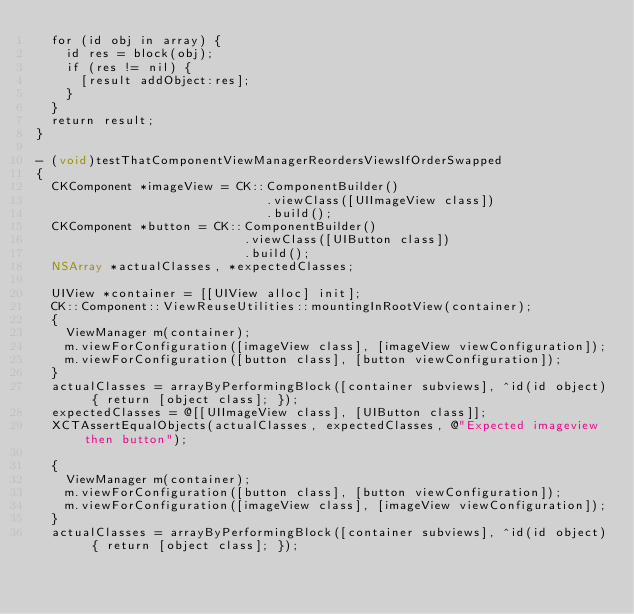Convert code to text. <code><loc_0><loc_0><loc_500><loc_500><_ObjectiveC_>  for (id obj in array) {
    id res = block(obj);
    if (res != nil) {
      [result addObject:res];
    }
  }
  return result;
}

- (void)testThatComponentViewManagerReordersViewsIfOrderSwapped
{
  CKComponent *imageView = CK::ComponentBuilder()
                               .viewClass([UIImageView class])
                               .build();
  CKComponent *button = CK::ComponentBuilder()
                            .viewClass([UIButton class])
                            .build();
  NSArray *actualClasses, *expectedClasses;

  UIView *container = [[UIView alloc] init];
  CK::Component::ViewReuseUtilities::mountingInRootView(container);
  {
    ViewManager m(container);
    m.viewForConfiguration([imageView class], [imageView viewConfiguration]);
    m.viewForConfiguration([button class], [button viewConfiguration]);
  }
  actualClasses = arrayByPerformingBlock([container subviews], ^id(id object) { return [object class]; });
  expectedClasses = @[[UIImageView class], [UIButton class]];
  XCTAssertEqualObjects(actualClasses, expectedClasses, @"Expected imageview then button");

  {
    ViewManager m(container);
    m.viewForConfiguration([button class], [button viewConfiguration]);
    m.viewForConfiguration([imageView class], [imageView viewConfiguration]);
  }
  actualClasses = arrayByPerformingBlock([container subviews], ^id(id object) { return [object class]; });</code> 